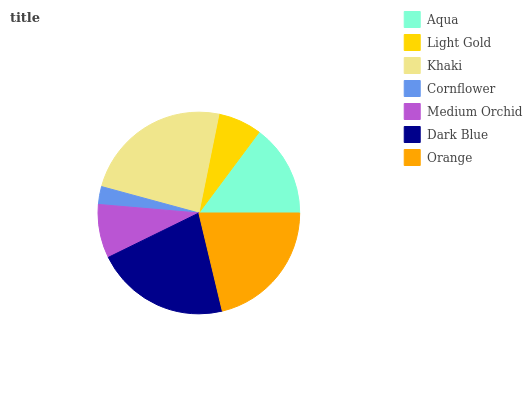Is Cornflower the minimum?
Answer yes or no. Yes. Is Khaki the maximum?
Answer yes or no. Yes. Is Light Gold the minimum?
Answer yes or no. No. Is Light Gold the maximum?
Answer yes or no. No. Is Aqua greater than Light Gold?
Answer yes or no. Yes. Is Light Gold less than Aqua?
Answer yes or no. Yes. Is Light Gold greater than Aqua?
Answer yes or no. No. Is Aqua less than Light Gold?
Answer yes or no. No. Is Aqua the high median?
Answer yes or no. Yes. Is Aqua the low median?
Answer yes or no. Yes. Is Medium Orchid the high median?
Answer yes or no. No. Is Dark Blue the low median?
Answer yes or no. No. 